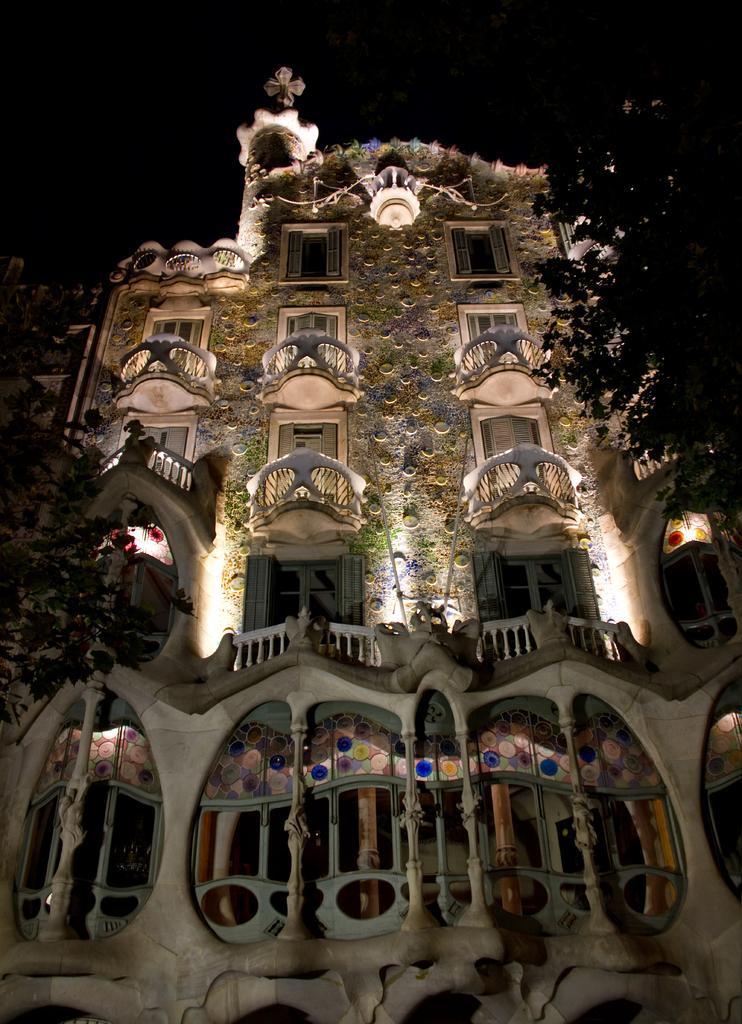How would you summarize this image in a sentence or two? In this image, we can see a building and there are some windows on the building, we can see the tree. 